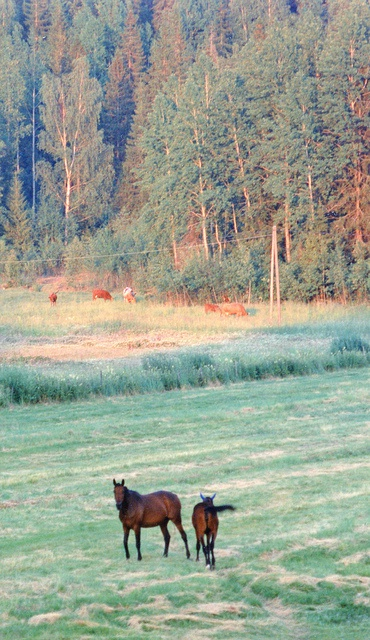Describe the objects in this image and their specific colors. I can see horse in darkgray, black, maroon, gray, and brown tones and horse in darkgray, black, maroon, and gray tones in this image. 